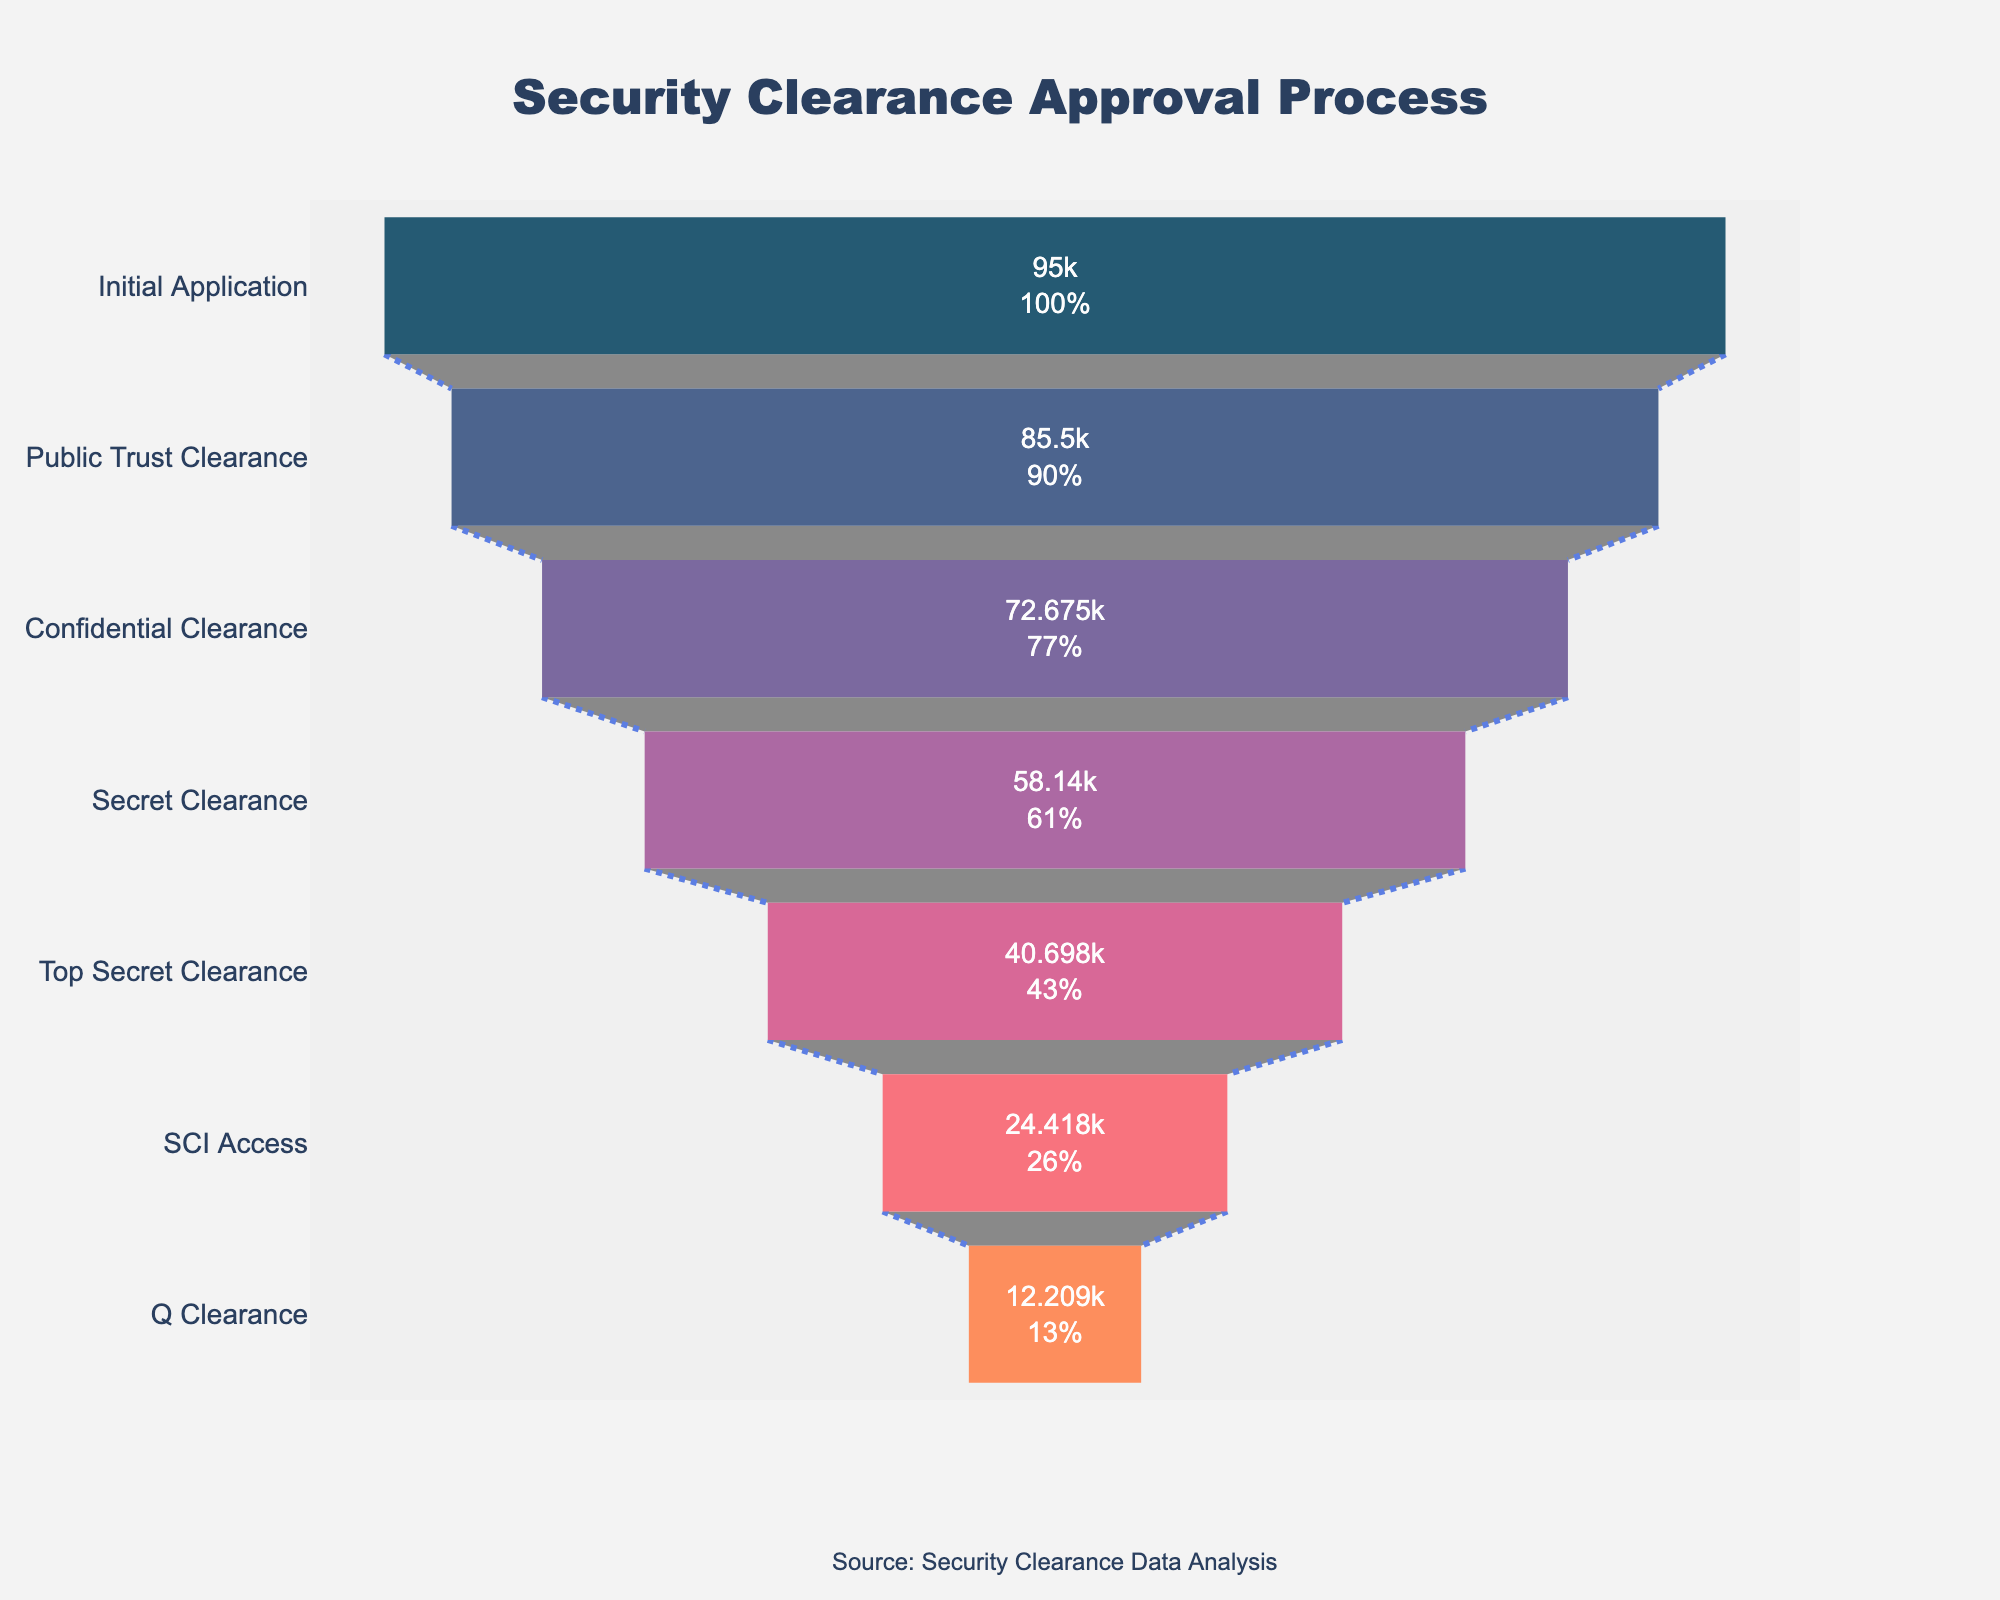What is the title of the funnel chart? The title is displayed at the top center of the chart with large bold font.
Answer: Security Clearance Approval Process How many levels are depicted in the funnel chart? There are seven distinct levels noted in the chart, each representing a stage in the approval process.
Answer: Seven What is the success rate for the Top Secret Clearance level? The chart displays the success rate next to each level's name. For Top Secret Clearance, it shows a 70% success rate.
Answer: 70% How many applicants successfully receive SCI Access clearance? The funnel chart shows the number of successful applicants at each level. For SCI Access clearance, the number is displayed as 40698.
Answer: 40698 Which clearance level has the lowest success rate? By examining the percentage success rates, the Q Clearance level has the lowest rate at 50%.
Answer: Q Clearance What is the difference in the number of successful applicants between the Public Trust Clearance and Q Clearance levels? The successive applicants for Public Trust Clearance are 85500 (90% of 95000), and for Q Clearance it is 24419 (50% of 48838). The difference is 85500 - 24419.
Answer: 61081 What percentage of initial applicants successfully reach Secret Clearance? Using the funnel percentages successively, 80% of the applicants from Confidential Clearance (85%) reach Secret Clearance. The calculation involves multiplying the percentages step-by-step.
Answer: 72.675% Compare the number of successful applicants for Confidential and Secret Clearance. Which one has more successful applicants? The chart shows that Confidential Clearance has 85500 successful applicants, while Secret Clearance has 72675. Confidential Clearance has more.
Answer: Confidential Clearance What's the cumulative drop in the number of applicants from Initial Application to SCI Access clearance? Starting with 100000 at Initial Application, a cumulative drop involves subtracting each subsequent number of successful applicants until SCI Access clearance. Specifically, 100000 - 40698.
Answer: 59302 How many more applicants get Public Trust Clearance than those who get Top Secret Clearance? Public Trust Clearance has 85500 successful applicants, and Top Secret Clearance has 58140. The difference is calculated by subtracting 58140 from 85500.
Answer: 27360 